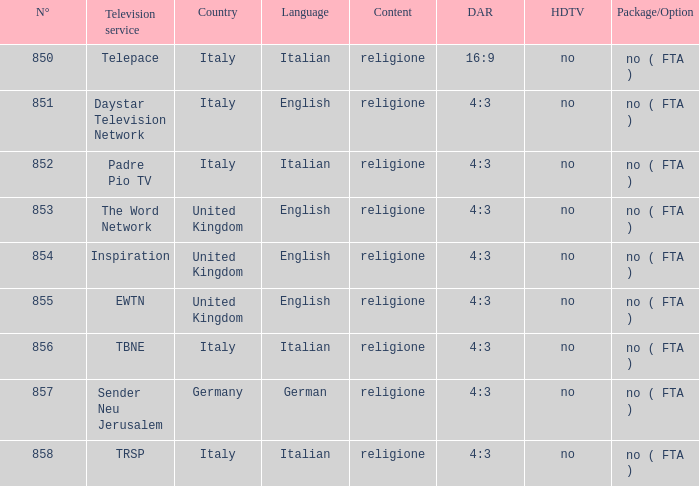What are the television services in the uk with channel numbers above 854.0? EWTN. Could you parse the entire table? {'header': ['N°', 'Television service', 'Country', 'Language', 'Content', 'DAR', 'HDTV', 'Package/Option'], 'rows': [['850', 'Telepace', 'Italy', 'Italian', 'religione', '16:9', 'no', 'no ( FTA )'], ['851', 'Daystar Television Network', 'Italy', 'English', 'religione', '4:3', 'no', 'no ( FTA )'], ['852', 'Padre Pio TV', 'Italy', 'Italian', 'religione', '4:3', 'no', 'no ( FTA )'], ['853', 'The Word Network', 'United Kingdom', 'English', 'religione', '4:3', 'no', 'no ( FTA )'], ['854', 'Inspiration', 'United Kingdom', 'English', 'religione', '4:3', 'no', 'no ( FTA )'], ['855', 'EWTN', 'United Kingdom', 'English', 'religione', '4:3', 'no', 'no ( FTA )'], ['856', 'TBNE', 'Italy', 'Italian', 'religione', '4:3', 'no', 'no ( FTA )'], ['857', 'Sender Neu Jerusalem', 'Germany', 'German', 'religione', '4:3', 'no', 'no ( FTA )'], ['858', 'TRSP', 'Italy', 'Italian', 'religione', '4:3', 'no', 'no ( FTA )']]} 